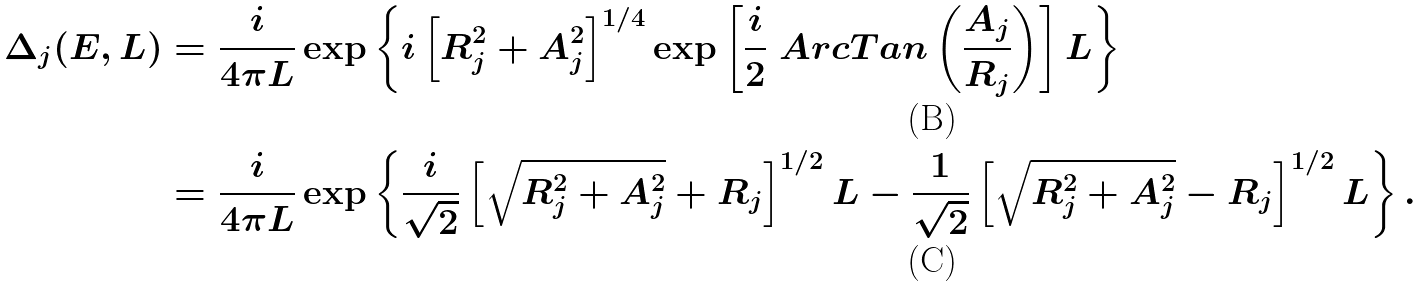Convert formula to latex. <formula><loc_0><loc_0><loc_500><loc_500>\Delta _ { j } ( E , L ) & = \frac { i } { 4 \pi L } \exp \left \{ i \left [ R ^ { 2 } _ { j } + A _ { j } ^ { 2 } \right ] ^ { 1 / 4 } \exp \left [ \frac { i } { 2 } \ A r c T a n \left ( \frac { A _ { j } } { R _ { j } } \right ) \right ] L \right \} \\ & = \frac { i } { 4 \pi L } \exp \left \{ \frac { i } { \sqrt { 2 } } \left [ \sqrt { R _ { j } ^ { 2 } + A _ { j } ^ { 2 } } + R _ { j } \right ] ^ { 1 / 2 } L - \frac { 1 } { \sqrt { 2 } } \left [ \sqrt { R _ { j } ^ { 2 } + A _ { j } ^ { 2 } } - R _ { j } \right ] ^ { 1 / 2 } L \right \} .</formula> 